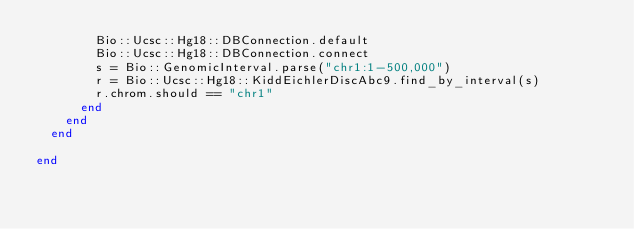Convert code to text. <code><loc_0><loc_0><loc_500><loc_500><_Ruby_>        Bio::Ucsc::Hg18::DBConnection.default
        Bio::Ucsc::Hg18::DBConnection.connect
        s = Bio::GenomicInterval.parse("chr1:1-500,000")
        r = Bio::Ucsc::Hg18::KiddEichlerDiscAbc9.find_by_interval(s)
        r.chrom.should == "chr1"
      end
    end
  end

end
</code> 